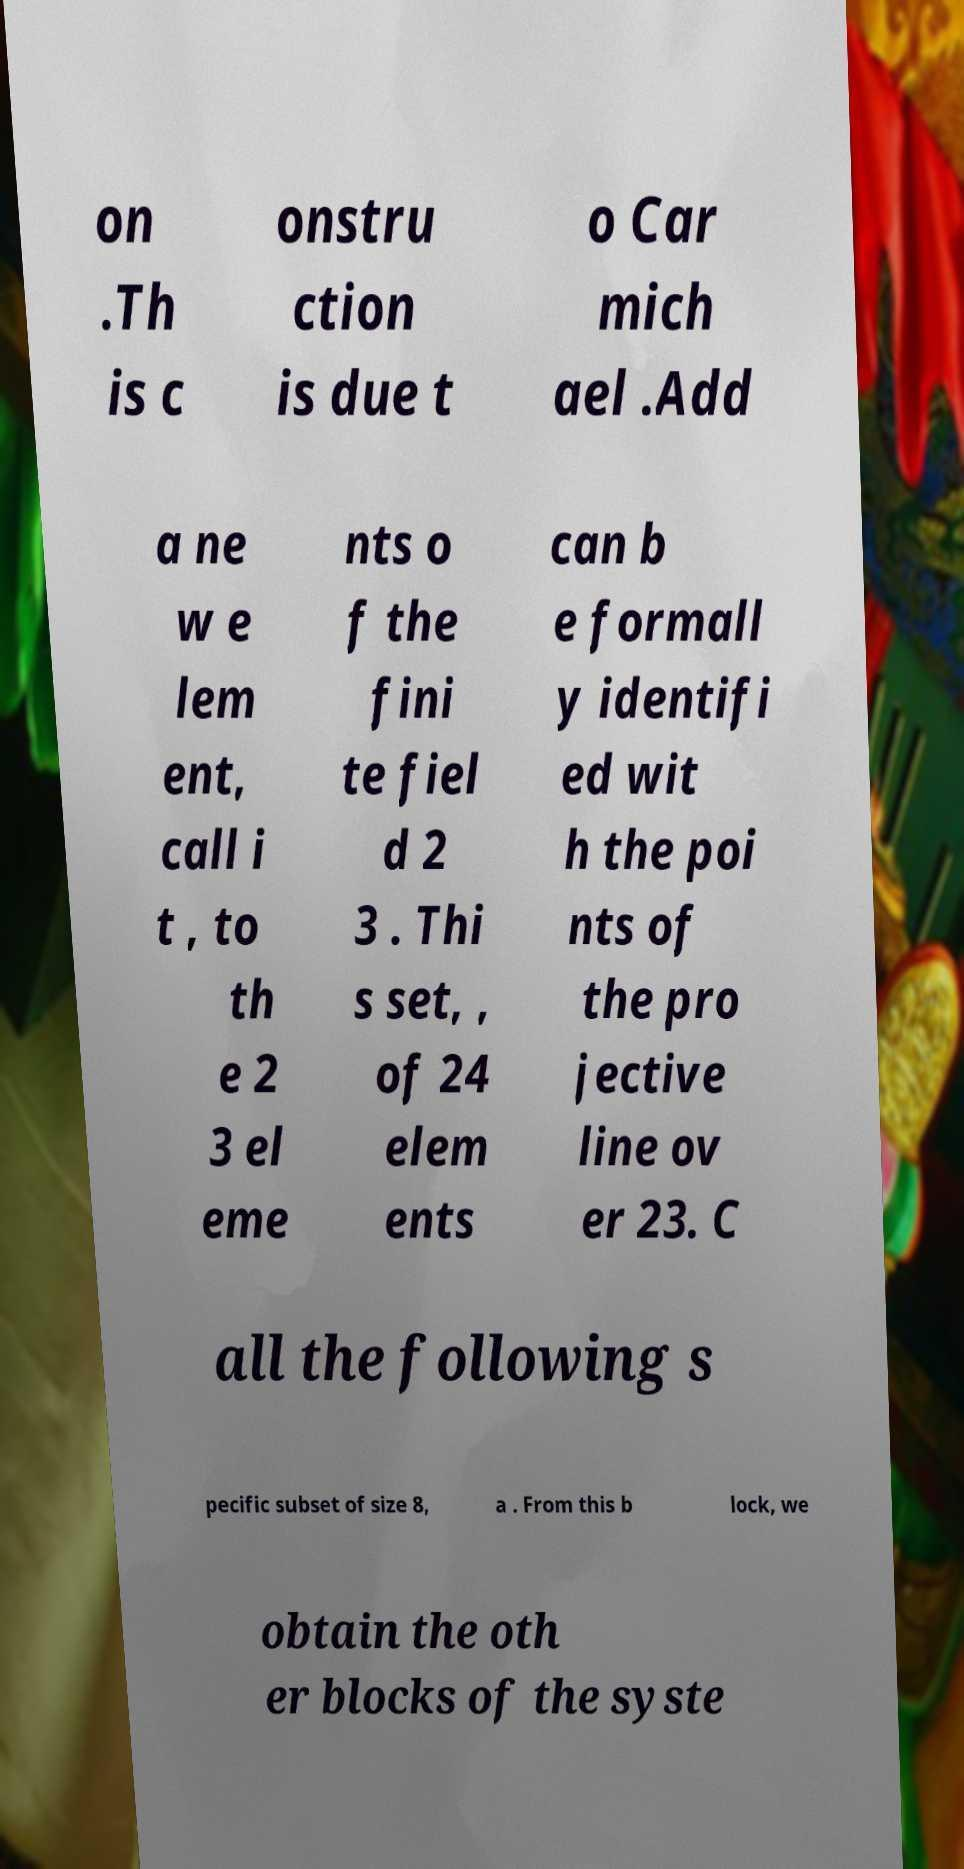Could you assist in decoding the text presented in this image and type it out clearly? on .Th is c onstru ction is due t o Car mich ael .Add a ne w e lem ent, call i t , to th e 2 3 el eme nts o f the fini te fiel d 2 3 . Thi s set, , of 24 elem ents can b e formall y identifi ed wit h the poi nts of the pro jective line ov er 23. C all the following s pecific subset of size 8, a . From this b lock, we obtain the oth er blocks of the syste 